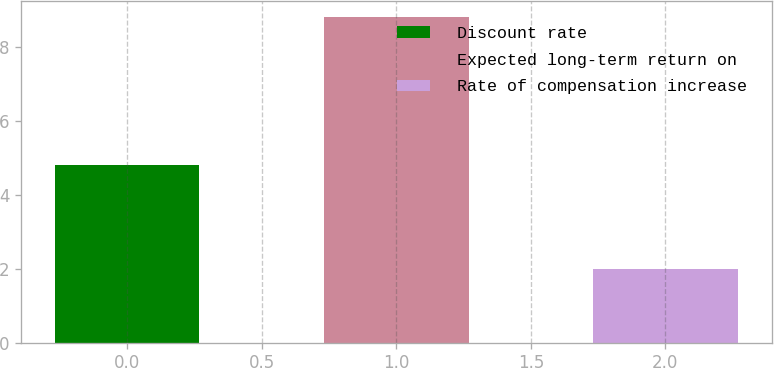Convert chart to OTSL. <chart><loc_0><loc_0><loc_500><loc_500><bar_chart><fcel>Discount rate<fcel>Expected long-term return on<fcel>Rate of compensation increase<nl><fcel>4.8<fcel>8.8<fcel>2<nl></chart> 